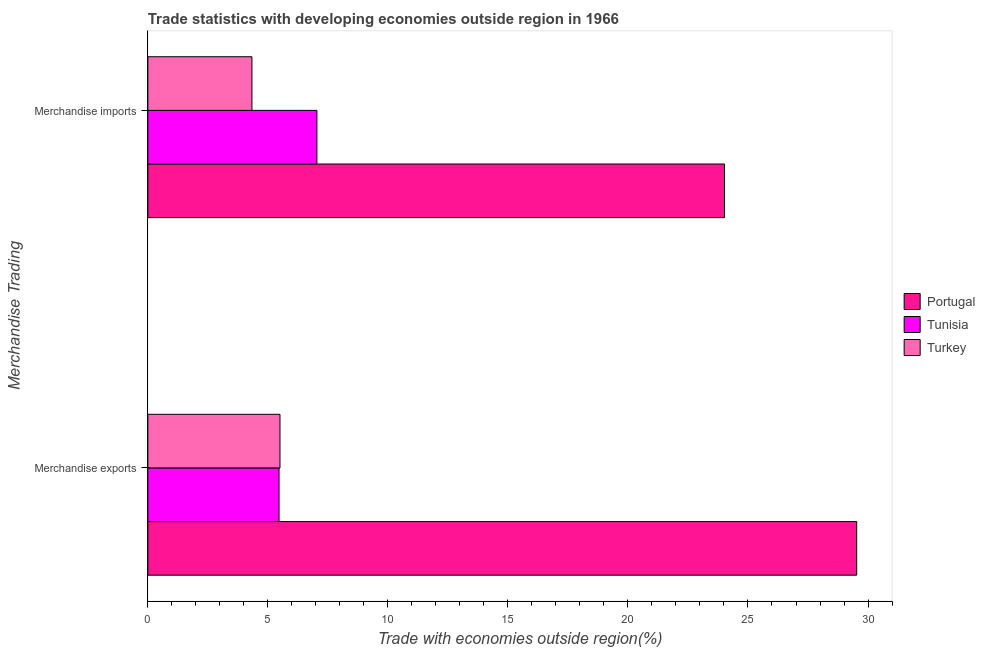How many bars are there on the 1st tick from the top?
Ensure brevity in your answer.  3. How many bars are there on the 1st tick from the bottom?
Offer a very short reply. 3. What is the label of the 1st group of bars from the top?
Ensure brevity in your answer.  Merchandise imports. What is the merchandise exports in Turkey?
Provide a short and direct response. 5.5. Across all countries, what is the maximum merchandise exports?
Keep it short and to the point. 29.53. Across all countries, what is the minimum merchandise imports?
Ensure brevity in your answer.  4.34. In which country was the merchandise imports minimum?
Provide a short and direct response. Turkey. What is the total merchandise exports in the graph?
Offer a very short reply. 40.5. What is the difference between the merchandise imports in Tunisia and that in Turkey?
Ensure brevity in your answer.  2.71. What is the difference between the merchandise exports in Turkey and the merchandise imports in Portugal?
Ensure brevity in your answer.  -18.52. What is the average merchandise exports per country?
Give a very brief answer. 13.5. What is the difference between the merchandise exports and merchandise imports in Turkey?
Provide a succinct answer. 1.17. What is the ratio of the merchandise imports in Turkey to that in Portugal?
Provide a succinct answer. 0.18. Is the merchandise exports in Tunisia less than that in Portugal?
Your response must be concise. Yes. What does the 2nd bar from the bottom in Merchandise imports represents?
Keep it short and to the point. Tunisia. Are all the bars in the graph horizontal?
Keep it short and to the point. Yes. Are the values on the major ticks of X-axis written in scientific E-notation?
Provide a short and direct response. No. Does the graph contain grids?
Your answer should be very brief. No. How many legend labels are there?
Offer a terse response. 3. What is the title of the graph?
Make the answer very short. Trade statistics with developing economies outside region in 1966. Does "Singapore" appear as one of the legend labels in the graph?
Your response must be concise. No. What is the label or title of the X-axis?
Your answer should be compact. Trade with economies outside region(%). What is the label or title of the Y-axis?
Your answer should be very brief. Merchandise Trading. What is the Trade with economies outside region(%) in Portugal in Merchandise exports?
Keep it short and to the point. 29.53. What is the Trade with economies outside region(%) of Tunisia in Merchandise exports?
Ensure brevity in your answer.  5.46. What is the Trade with economies outside region(%) in Turkey in Merchandise exports?
Give a very brief answer. 5.5. What is the Trade with economies outside region(%) of Portugal in Merchandise imports?
Offer a terse response. 24.02. What is the Trade with economies outside region(%) in Tunisia in Merchandise imports?
Ensure brevity in your answer.  7.04. What is the Trade with economies outside region(%) in Turkey in Merchandise imports?
Keep it short and to the point. 4.34. Across all Merchandise Trading, what is the maximum Trade with economies outside region(%) in Portugal?
Make the answer very short. 29.53. Across all Merchandise Trading, what is the maximum Trade with economies outside region(%) of Tunisia?
Your response must be concise. 7.04. Across all Merchandise Trading, what is the maximum Trade with economies outside region(%) in Turkey?
Provide a succinct answer. 5.5. Across all Merchandise Trading, what is the minimum Trade with economies outside region(%) in Portugal?
Offer a terse response. 24.02. Across all Merchandise Trading, what is the minimum Trade with economies outside region(%) of Tunisia?
Keep it short and to the point. 5.46. Across all Merchandise Trading, what is the minimum Trade with economies outside region(%) of Turkey?
Your response must be concise. 4.34. What is the total Trade with economies outside region(%) in Portugal in the graph?
Make the answer very short. 53.55. What is the total Trade with economies outside region(%) in Tunisia in the graph?
Your response must be concise. 12.51. What is the total Trade with economies outside region(%) in Turkey in the graph?
Offer a terse response. 9.84. What is the difference between the Trade with economies outside region(%) in Portugal in Merchandise exports and that in Merchandise imports?
Make the answer very short. 5.51. What is the difference between the Trade with economies outside region(%) in Tunisia in Merchandise exports and that in Merchandise imports?
Your answer should be compact. -1.58. What is the difference between the Trade with economies outside region(%) of Turkey in Merchandise exports and that in Merchandise imports?
Your response must be concise. 1.17. What is the difference between the Trade with economies outside region(%) in Portugal in Merchandise exports and the Trade with economies outside region(%) in Tunisia in Merchandise imports?
Make the answer very short. 22.49. What is the difference between the Trade with economies outside region(%) of Portugal in Merchandise exports and the Trade with economies outside region(%) of Turkey in Merchandise imports?
Provide a short and direct response. 25.19. What is the difference between the Trade with economies outside region(%) of Tunisia in Merchandise exports and the Trade with economies outside region(%) of Turkey in Merchandise imports?
Provide a short and direct response. 1.13. What is the average Trade with economies outside region(%) in Portugal per Merchandise Trading?
Make the answer very short. 26.78. What is the average Trade with economies outside region(%) of Tunisia per Merchandise Trading?
Keep it short and to the point. 6.25. What is the average Trade with economies outside region(%) of Turkey per Merchandise Trading?
Your response must be concise. 4.92. What is the difference between the Trade with economies outside region(%) of Portugal and Trade with economies outside region(%) of Tunisia in Merchandise exports?
Offer a very short reply. 24.06. What is the difference between the Trade with economies outside region(%) in Portugal and Trade with economies outside region(%) in Turkey in Merchandise exports?
Offer a very short reply. 24.03. What is the difference between the Trade with economies outside region(%) of Tunisia and Trade with economies outside region(%) of Turkey in Merchandise exports?
Your response must be concise. -0.04. What is the difference between the Trade with economies outside region(%) of Portugal and Trade with economies outside region(%) of Tunisia in Merchandise imports?
Offer a terse response. 16.98. What is the difference between the Trade with economies outside region(%) of Portugal and Trade with economies outside region(%) of Turkey in Merchandise imports?
Offer a very short reply. 19.69. What is the difference between the Trade with economies outside region(%) in Tunisia and Trade with economies outside region(%) in Turkey in Merchandise imports?
Your answer should be very brief. 2.71. What is the ratio of the Trade with economies outside region(%) of Portugal in Merchandise exports to that in Merchandise imports?
Offer a terse response. 1.23. What is the ratio of the Trade with economies outside region(%) in Tunisia in Merchandise exports to that in Merchandise imports?
Offer a very short reply. 0.78. What is the ratio of the Trade with economies outside region(%) of Turkey in Merchandise exports to that in Merchandise imports?
Your answer should be very brief. 1.27. What is the difference between the highest and the second highest Trade with economies outside region(%) of Portugal?
Offer a very short reply. 5.51. What is the difference between the highest and the second highest Trade with economies outside region(%) in Tunisia?
Ensure brevity in your answer.  1.58. What is the difference between the highest and the second highest Trade with economies outside region(%) of Turkey?
Offer a terse response. 1.17. What is the difference between the highest and the lowest Trade with economies outside region(%) of Portugal?
Provide a succinct answer. 5.51. What is the difference between the highest and the lowest Trade with economies outside region(%) in Tunisia?
Keep it short and to the point. 1.58. What is the difference between the highest and the lowest Trade with economies outside region(%) in Turkey?
Your answer should be compact. 1.17. 